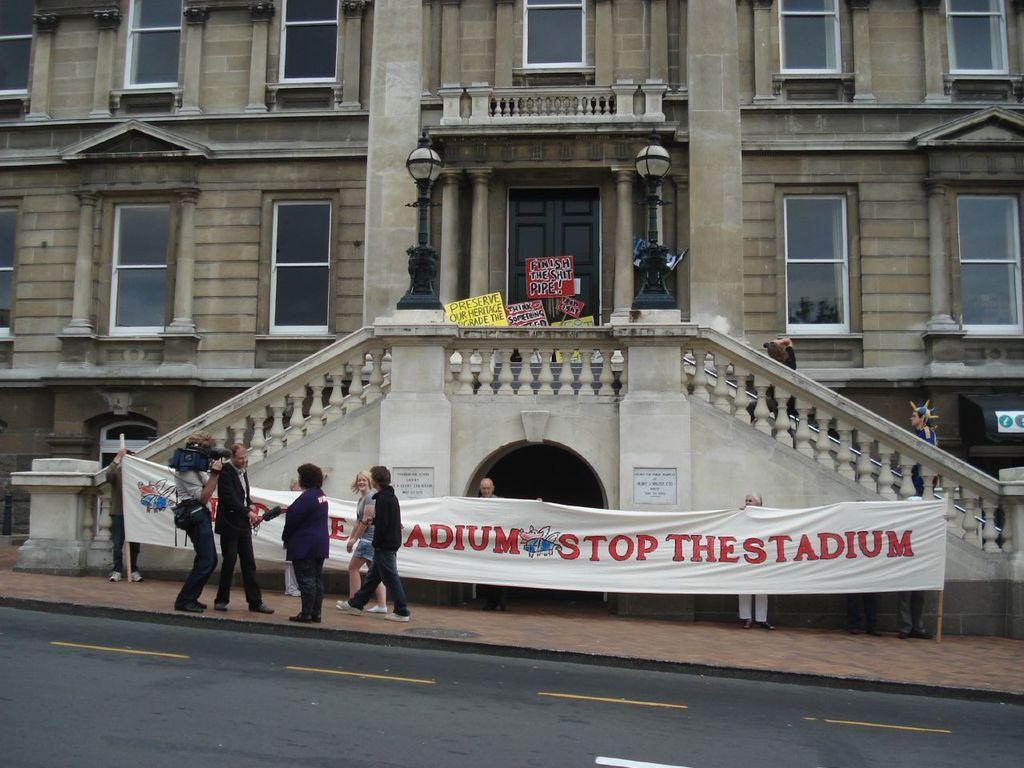Could you give a brief overview of what you see in this image? This image is clicked on the road. Beside the road there is a walkway. There are a few people walking on the walkway. There is a person holding a camera in his hand. Beside him there is another person holding a microphone in his hand. Behind them there are people holding a banner. There is text on the banner. In the background there is a building. There are glass windows, a door, lights and a railing to the building. There are many boards near the door. 